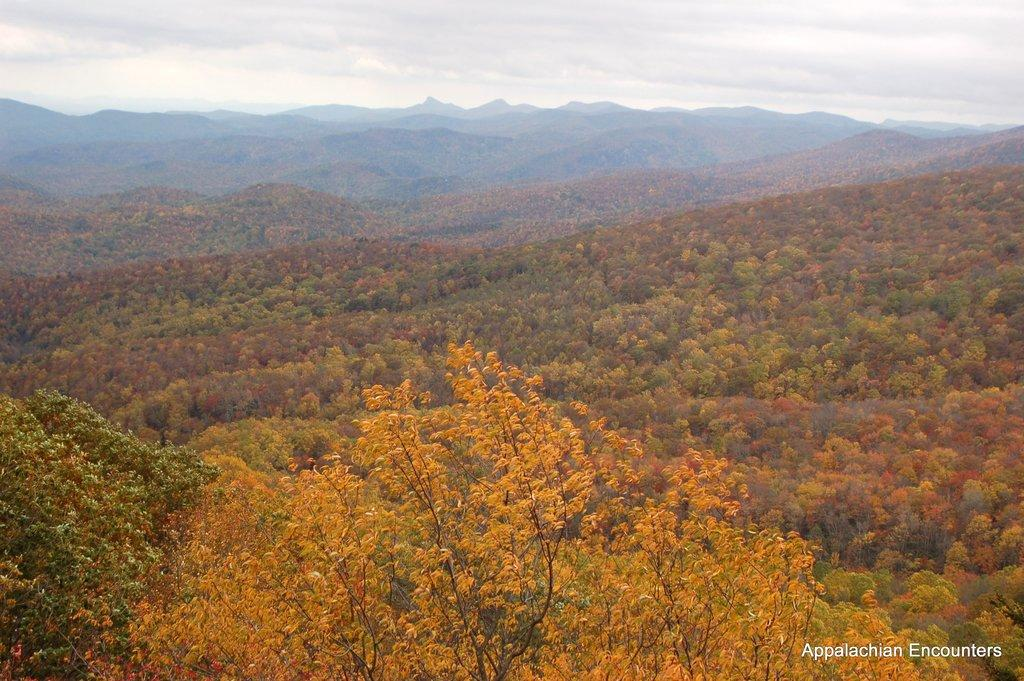What type of landscape is depicted in the image? The image features many hills and trees. What is the condition of the sky in the image? The sky is cloudy in the image. Where is the throne located in the image? There is no throne present in the image. Can you tell me how many people are joining the group on the street in the image? There is no street or group of people in the image. 